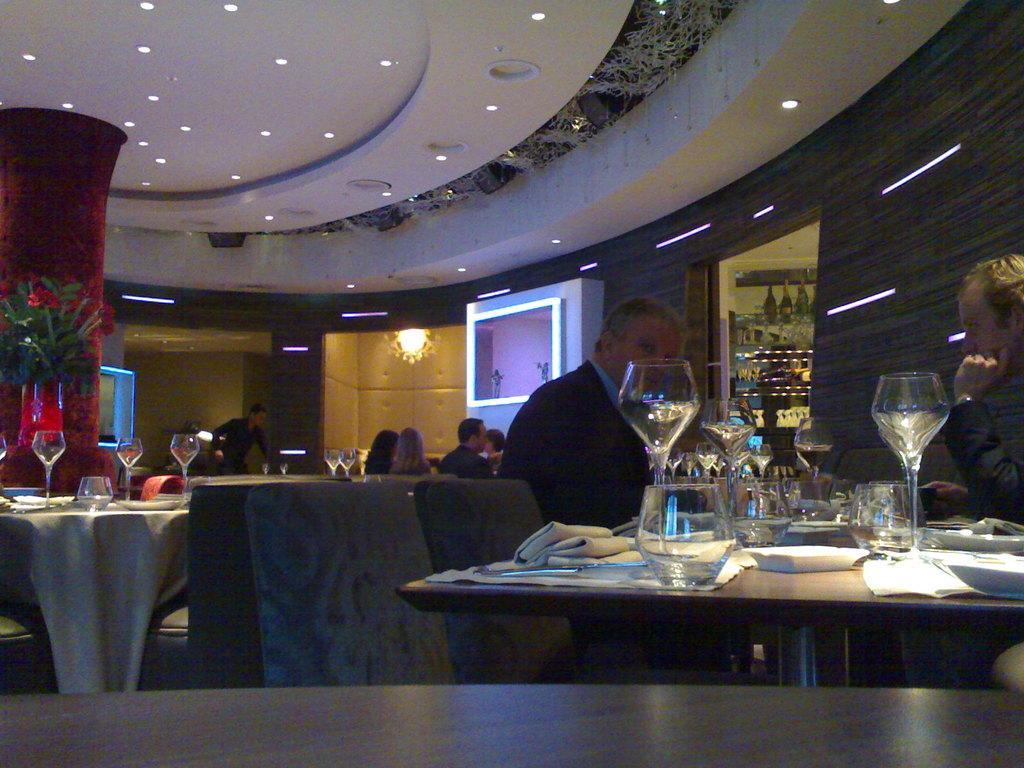How would you summarize this image in a sentence or two? This is a picture taken in a restaurant, there are a group of people sitting on a chair in front of this people there is a table on the table there is a glasses, plate, tissue, spoon and a cloth. Background of this people there is a wall on top of them there is a ceiling lights. 